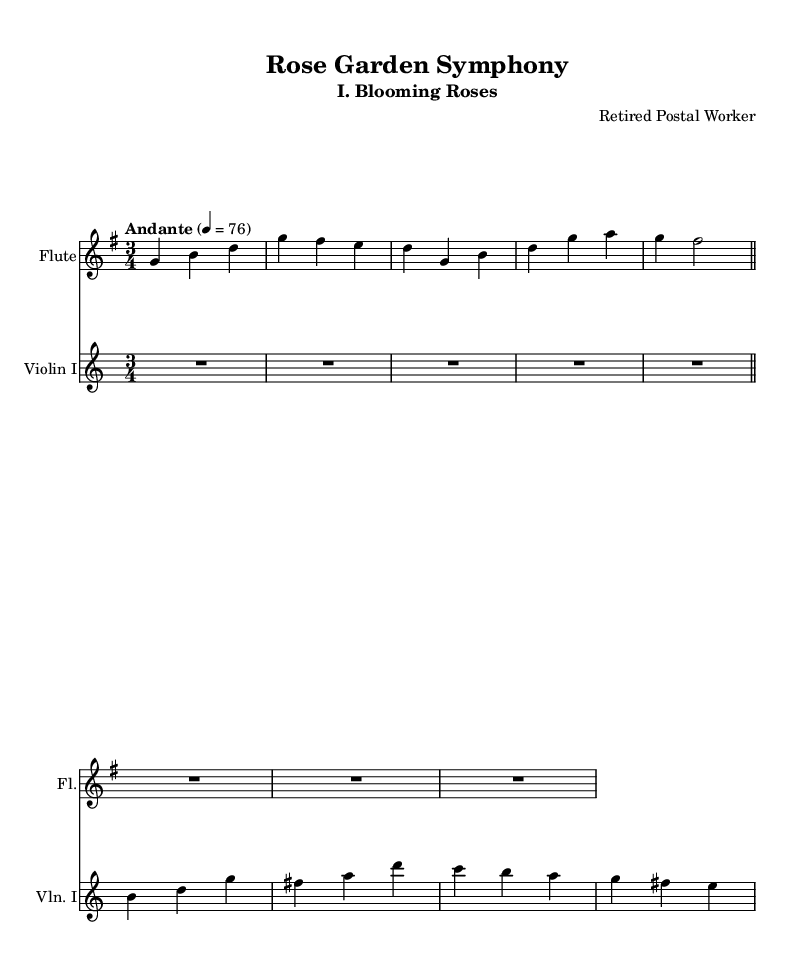What is the title of this piece? The title is found at the top of the sheet music, labeled as "Rose Garden Symphony."
Answer: Rose Garden Symphony What is the time signature? The time signature is indicated at the beginning of the music, expressed as "3/4." This means there are three beats in each measure.
Answer: 3/4 What is the key signature of this piece? The key signature appears at the beginning of the music. It has one sharp, indicating that the piece is in G major.
Answer: G major What tempo marking is indicated? The tempo marking is indicated at the beginning, stating "Andante," which generally suggests a moderately slow pace.
Answer: Andante Which instrument is playing in this section? The instruments are named at the start of each staff. The first staff is labeled "Flute," and the second staff is labeled "Violin I."
Answer: Flute Which dynamic symbol might typically be expected in a pastoral symphony like this? While it may not be explicitly shown in this excerpt, pastoral symphonies often have softer dynamics to reflect the serenity of nature, such as "p" for piano. In this case, we infer that "p" may commonly be expected in a piece named "Rose Garden Symphony."
Answer: p 